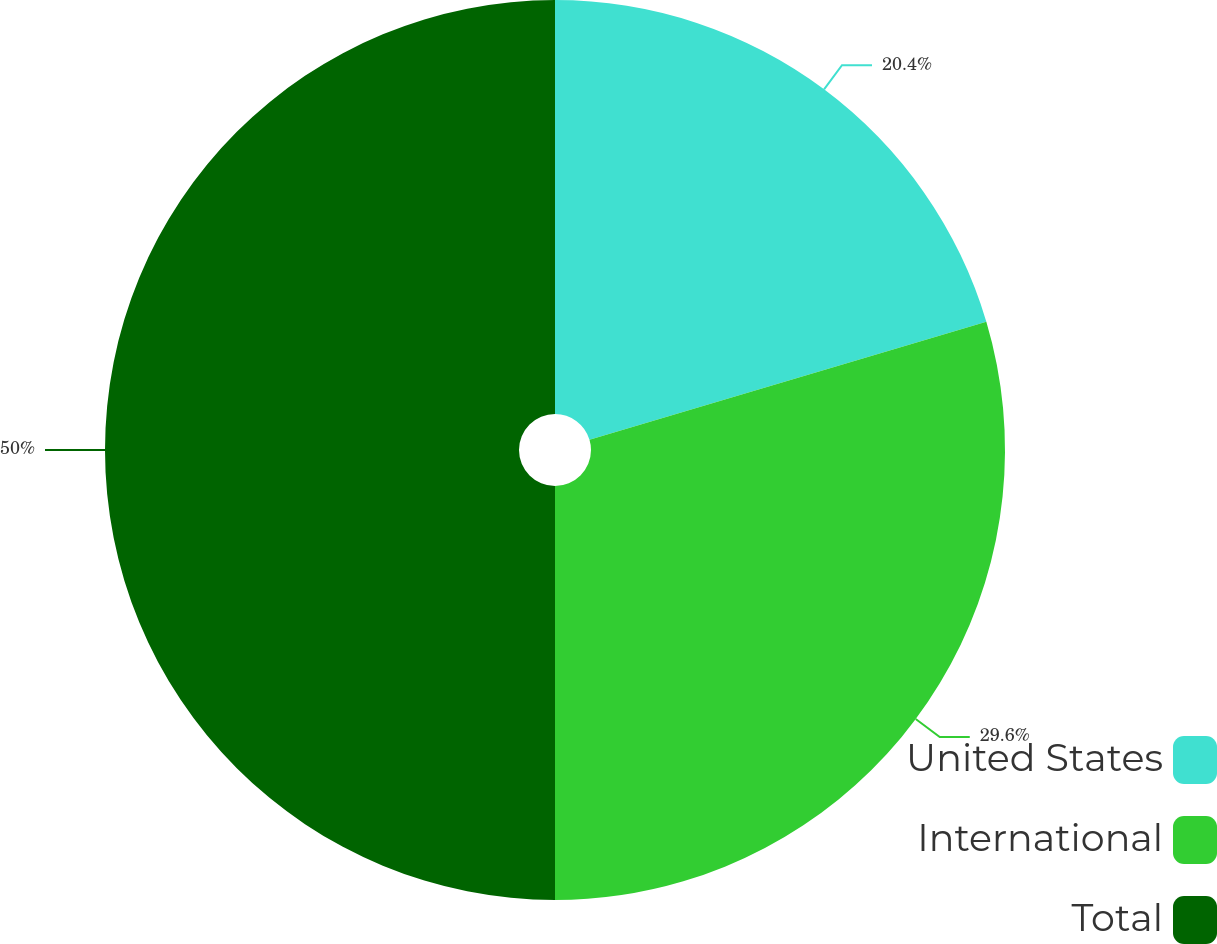<chart> <loc_0><loc_0><loc_500><loc_500><pie_chart><fcel>United States<fcel>International<fcel>Total<nl><fcel>20.4%<fcel>29.6%<fcel>50.0%<nl></chart> 